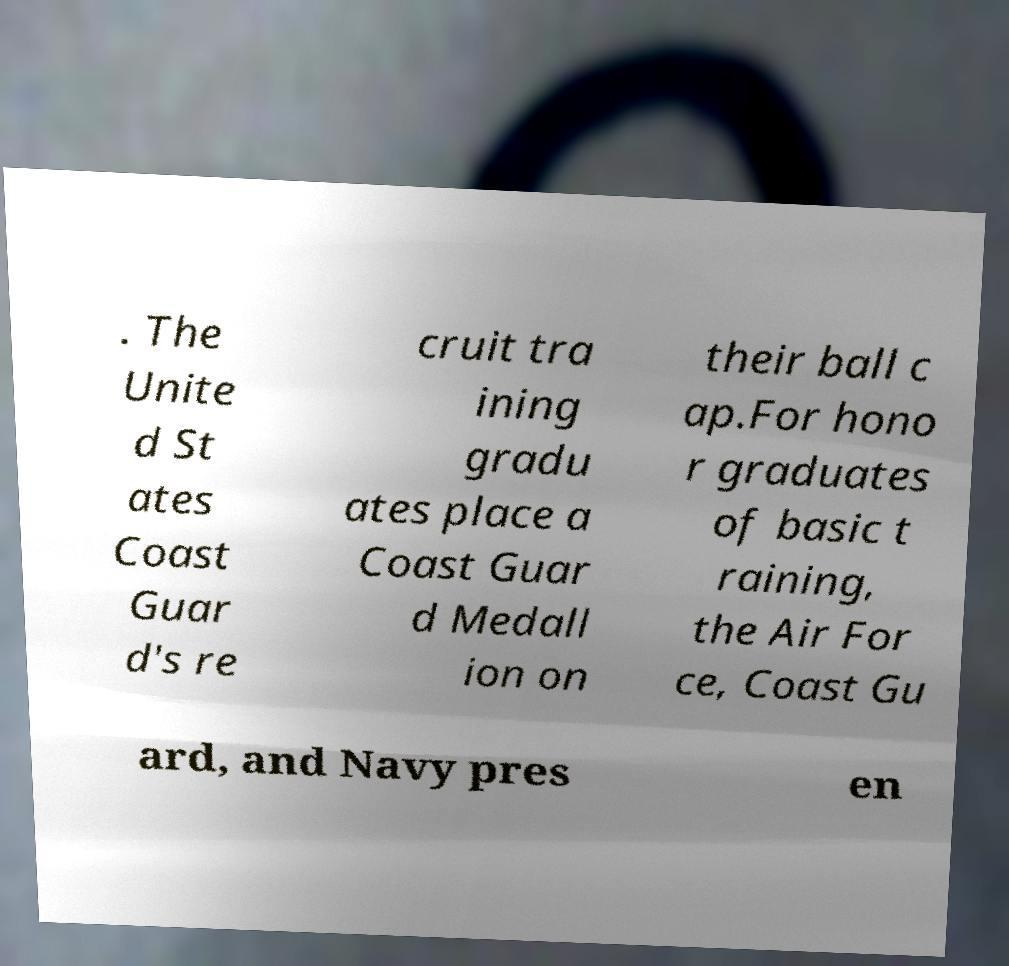Could you assist in decoding the text presented in this image and type it out clearly? . The Unite d St ates Coast Guar d's re cruit tra ining gradu ates place a Coast Guar d Medall ion on their ball c ap.For hono r graduates of basic t raining, the Air For ce, Coast Gu ard, and Navy pres en 